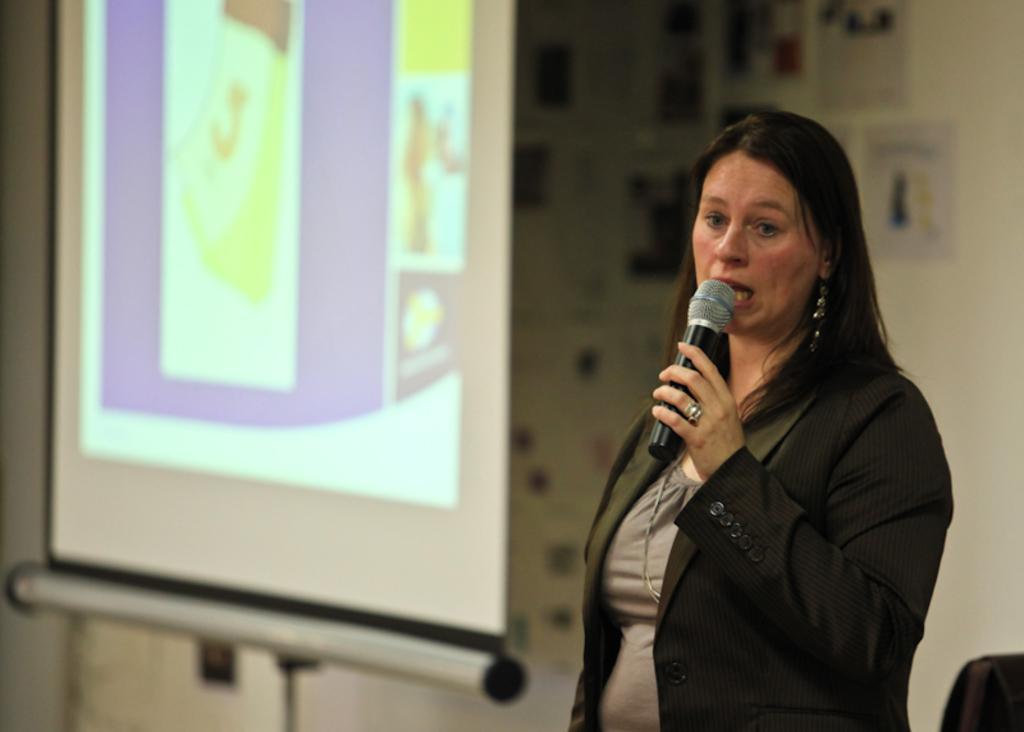In one or two sentences, can you explain what this image depicts? A woman is standing holding a microphone and wearing a blazer. There is a projector display at the back. 